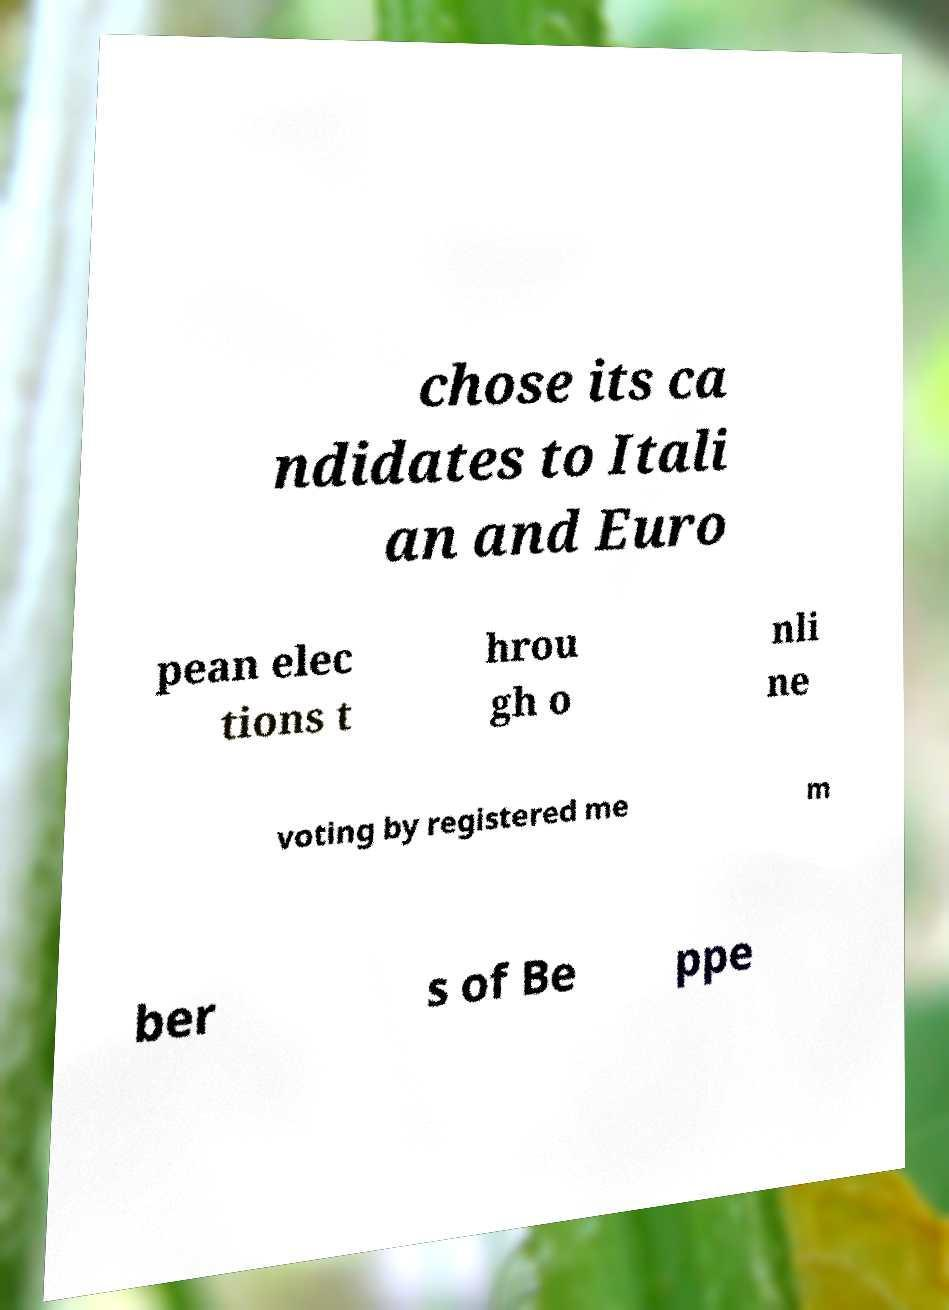Can you read and provide the text displayed in the image?This photo seems to have some interesting text. Can you extract and type it out for me? chose its ca ndidates to Itali an and Euro pean elec tions t hrou gh o nli ne voting by registered me m ber s of Be ppe 